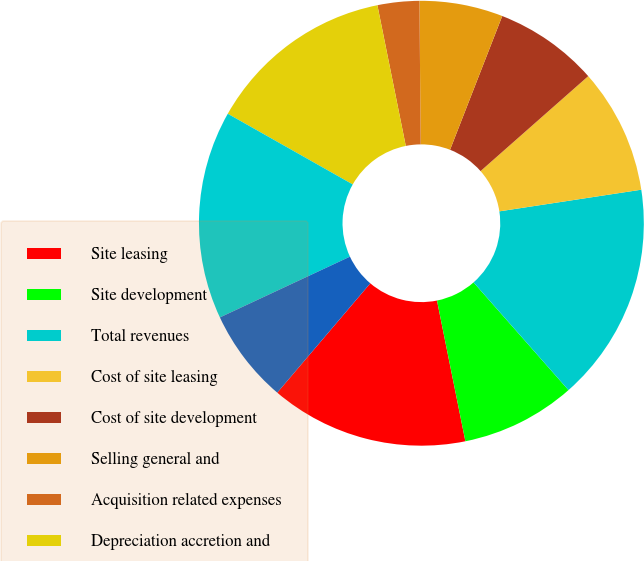Convert chart. <chart><loc_0><loc_0><loc_500><loc_500><pie_chart><fcel>Site leasing<fcel>Site development<fcel>Total revenues<fcel>Cost of site leasing<fcel>Cost of site development<fcel>Selling general and<fcel>Acquisition related expenses<fcel>Depreciation accretion and<fcel>Total operating expenses<fcel>Operating income<nl><fcel>14.39%<fcel>8.33%<fcel>15.91%<fcel>9.09%<fcel>7.58%<fcel>6.06%<fcel>3.03%<fcel>13.64%<fcel>15.15%<fcel>6.82%<nl></chart> 